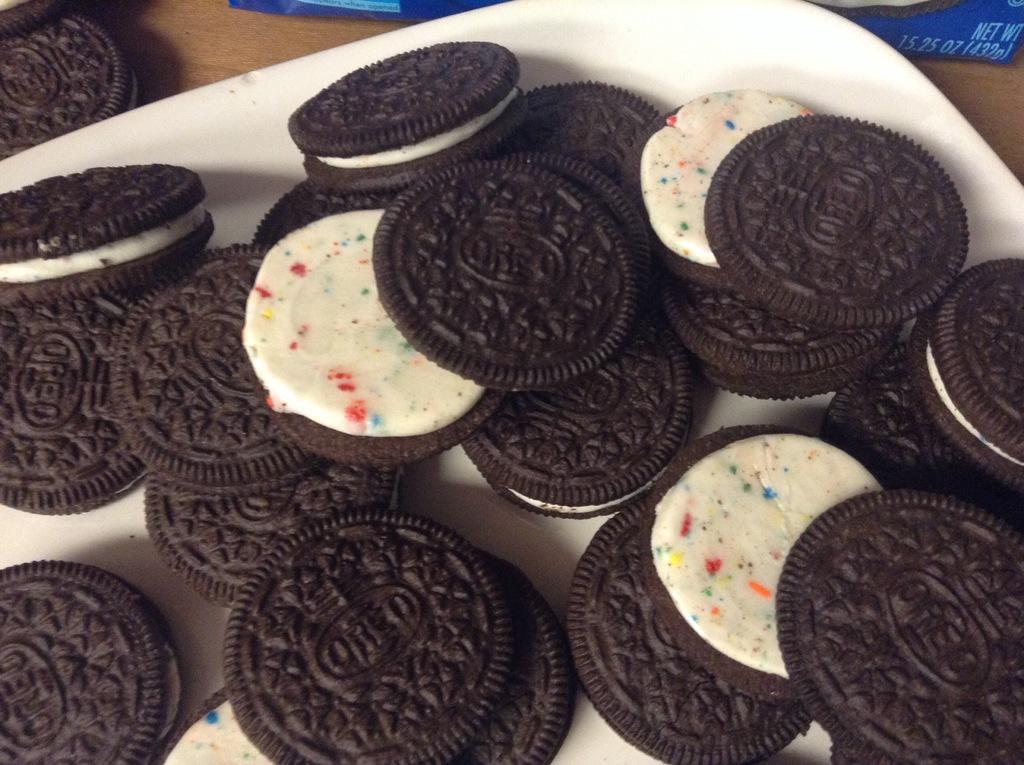Describe this image in one or two sentences. In this image I see a lot of Oreo biscuits which are of brown color and cream in between and they all are on a plate. 